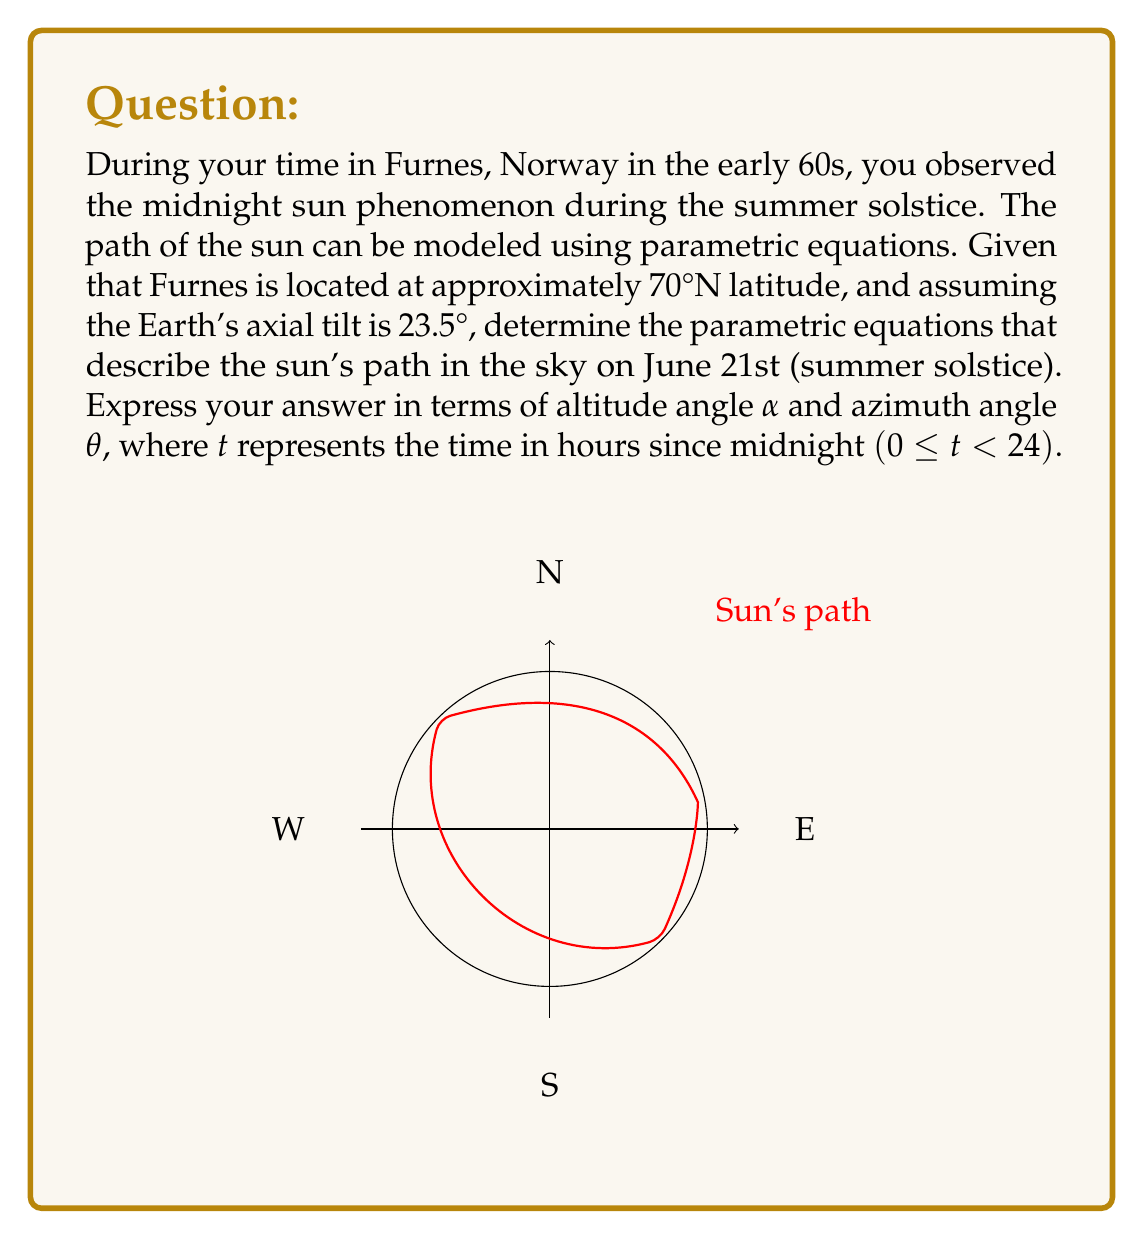Could you help me with this problem? To solve this problem, we'll follow these steps:

1) First, we need to calculate the sun's maximum altitude angle at solar noon:
   $$α_{max} = 90° - |latitude - axial tilt|$$
   $$α_{max} = 90° - |70° - 23.5°| = 43.5°$$

2) The altitude angle α varies sinusoidally over 24 hours:
   $$α(t) = α_{max} \sin(\frac{\pi}{12}t)$$

3) For the azimuth angle θ, we need to consider that the sun completes a full 360° rotation in 24 hours, but it's offset by 180° at midnight:
   $$θ(t) = \frac{\pi}{12}t + \pi$$

4) However, we need to adjust this for the fact that the sun doesn't set. Instead, it reaches its minimum point in the north. We can model this with a piecewise function:

   $$θ(t) = \begin{cases} 
   \frac{\pi}{12}t + \pi & \text{if } 0 \leq t < 12 \\
   \frac{\pi}{12}t - \pi & \text{if } 12 \leq t < 24
   \end{cases}$$

5) Therefore, our final parametric equations are:

   $$α(t) = 43.5° \sin(\frac{\pi}{12}t)$$
   
   $$θ(t) = \begin{cases} 
   \frac{\pi}{12}t + \pi & \text{if } 0 \leq t < 12 \\
   \frac{\pi}{12}t - \pi & \text{if } 12 \leq t < 24
   \end{cases}$$

Where t is in hours since midnight, α is in degrees, and θ is in radians.
Answer: $$α(t) = 43.5° \sin(\frac{\pi}{12}t), \quad θ(t) = \begin{cases} 
\frac{\pi}{12}t + \pi & \text{if } 0 \leq t < 12 \\
\frac{\pi}{12}t - \pi & \text{if } 12 \leq t < 24
\end{cases}$$ 